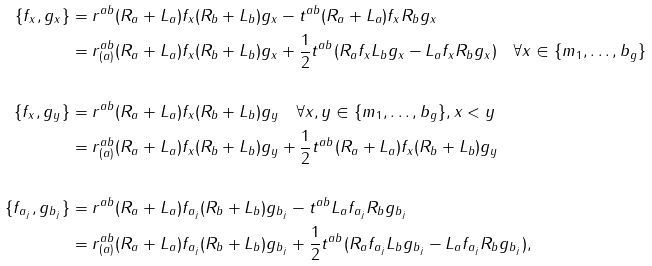Convert formula to latex. <formula><loc_0><loc_0><loc_500><loc_500>\{ f _ { x } , g _ { x } \} & = r ^ { a b } ( R _ { a } + L _ { a } ) f _ { x } ( R _ { b } + L _ { b } ) g _ { x } - t ^ { a b } ( R _ { a } + L _ { a } ) f _ { x } R _ { b } g _ { x } \\ & = r ^ { a b } _ { ( a ) } ( R _ { a } + L _ { a } ) f _ { x } ( R _ { b } + L _ { b } ) g _ { x } + \frac { 1 } { 2 } t ^ { a b } ( R _ { a } f _ { x } L _ { b } g _ { x } - L _ { a } f _ { x } R _ { b } g _ { x } ) \quad \forall x \in \{ m _ { 1 } , \dots , b _ { g } \} \\ \\ \{ f _ { x } , g _ { y } \} & = r ^ { a b } ( R _ { a } + L _ { a } ) f _ { x } ( R _ { b } + L _ { b } ) g _ { y } \quad \forall x , y \in \{ m _ { 1 } , \dots , b _ { g } \} , x < y \\ & = r ^ { a b } _ { ( a ) } ( R _ { a } + L _ { a } ) f _ { x } ( R _ { b } + L _ { b } ) g _ { y } + \frac { 1 } { 2 } t ^ { a b } ( R _ { a } + L _ { a } ) f _ { x } ( R _ { b } + L _ { b } ) g _ { y } \\ \\ \{ f _ { a _ { j } } , g _ { b _ { j } } \} & = r ^ { a b } ( R _ { a } + L _ { a } ) f _ { a _ { j } } ( R _ { b } + L _ { b } ) g _ { b _ { j } } - t ^ { a b } L _ { a } f _ { a _ { j } } R _ { b } g _ { b _ { j } } \\ & = r ^ { a b } _ { ( a ) } ( R _ { a } + L _ { a } ) f _ { a _ { j } } ( R _ { b } + L _ { b } ) g _ { b _ { j } } + \frac { 1 } { 2 } t ^ { a b } ( R _ { a } f _ { a _ { j } } L _ { b } g _ { b _ { j } } - L _ { a } f _ { a _ { j } } R _ { b } g _ { b _ { j } } ) ,</formula> 